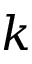Convert formula to latex. <formula><loc_0><loc_0><loc_500><loc_500>k</formula> 